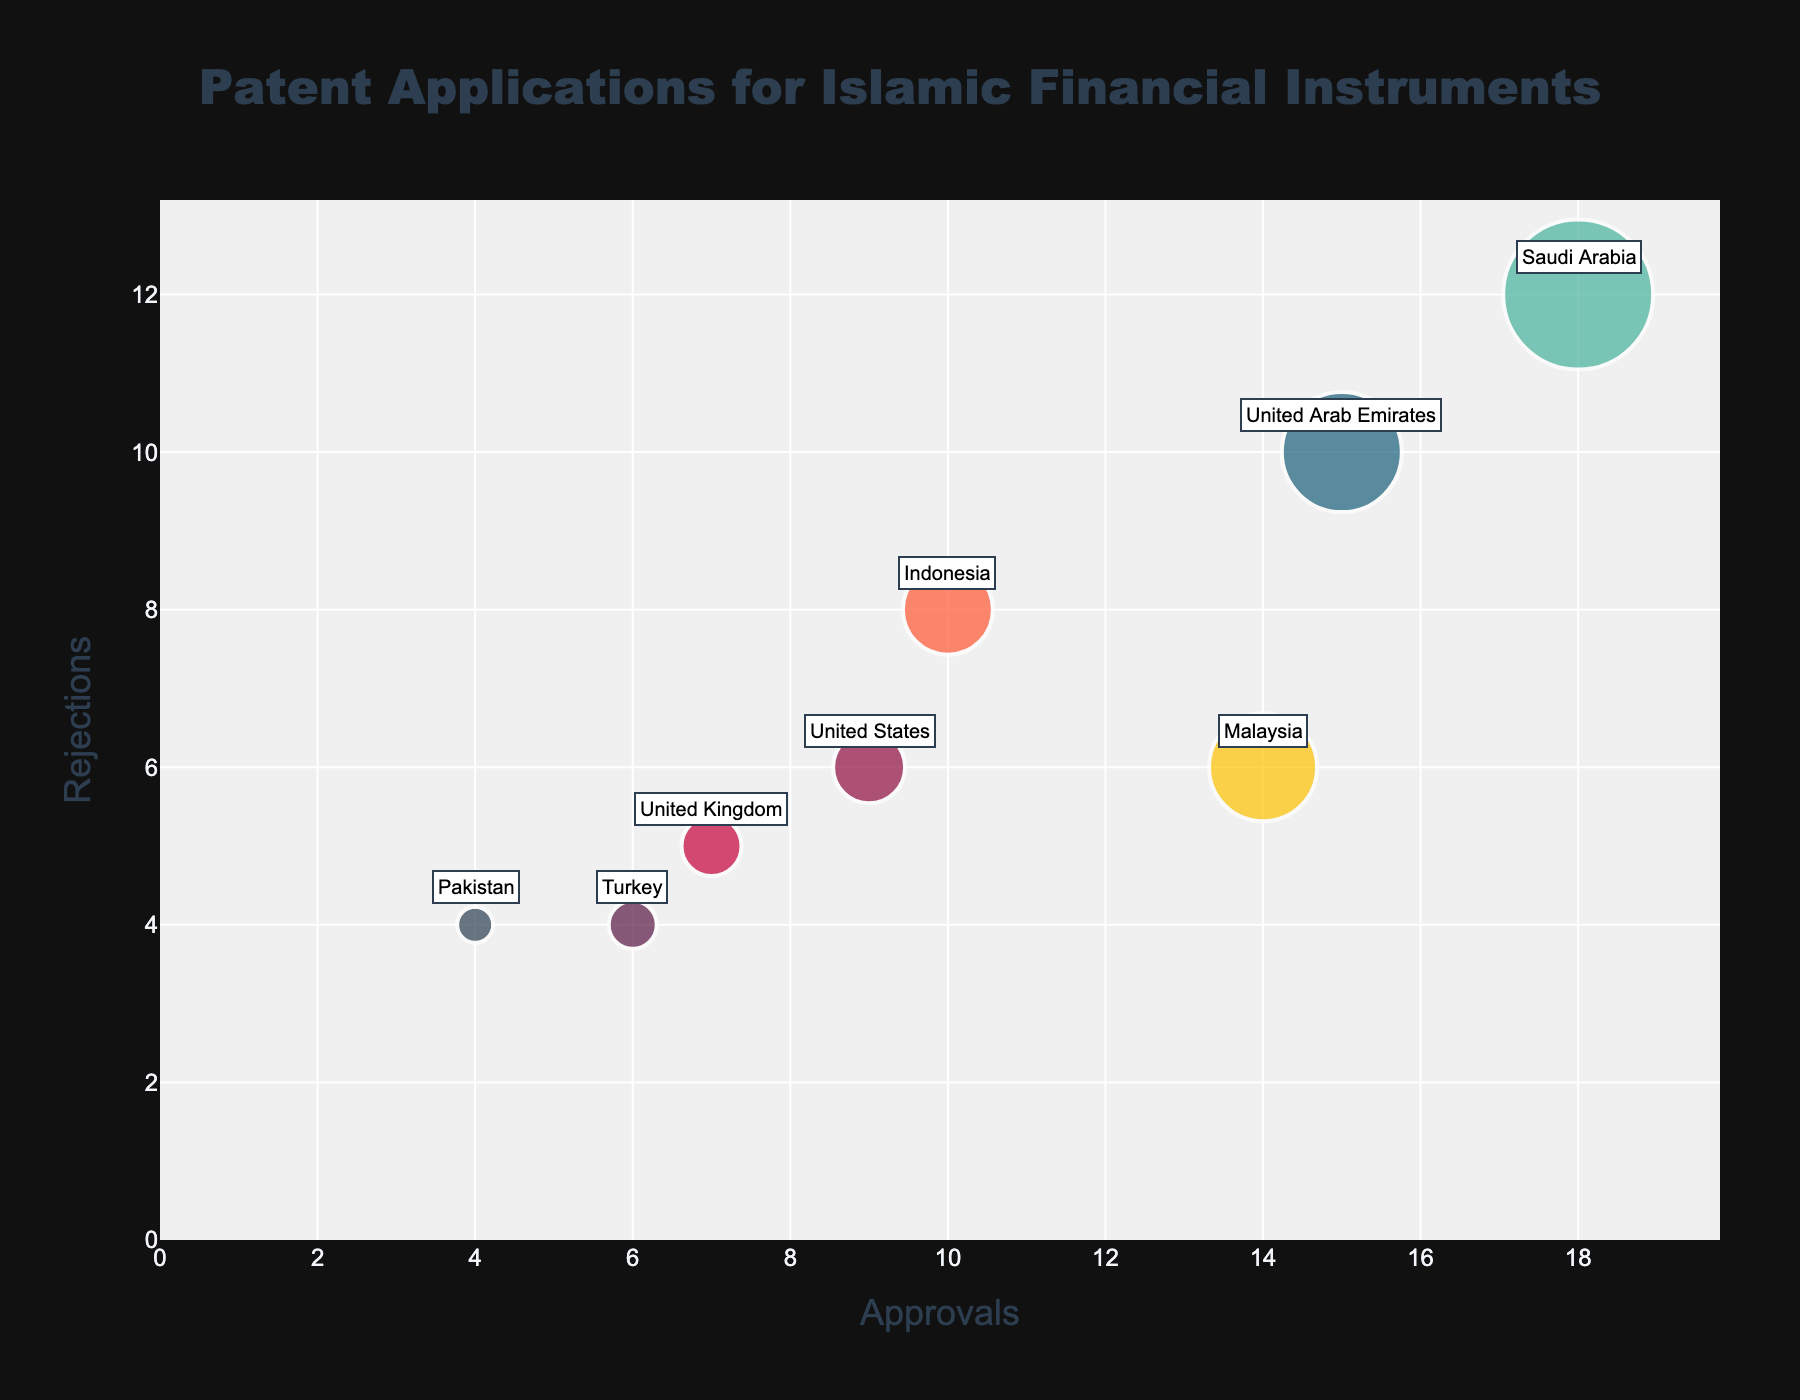what is the title of the figure? The title of the figure is displayed at the top of the chart. It reads "Patent Applications for Islamic Financial Instruments".
Answer: Patent Applications for Islamic Financial Instruments How many countries are represented in the chart? By counting the number of unique data points (bubbles) in the chart, we observe that there are various bubbles, each representing a different country. Upon inspection, we identify 8 distinct countries presented.
Answer: 8 Which country has the highest number of approvals? By examining the x-axis, which represents the number of approvals, and identifying the bubble that is farthest to the right, we see that Saudi Arabia has the highest number of approvals, with an approval count of 18.
Answer: Saudi Arabia What is the sum of rejections for Malaysia and Indonesia? To calculate this, we refer to the y-axis values for Malaysia and Indonesia. Malaysia has 6 rejections and Indonesia has 8 rejections. Adding these two values, 6 + 8, gives us 14.
Answer: 14 Which country has the smallest bubble size, and what does it represent? By identifying the smallest bubble on the chart, it corresponds to Pakistan. The bubble size represents the number of patent applications, and according to the given data, Pakistan has 8 patent applications.
Answer: Pakistan; 8 patent applications How many more approvals does the United States have compared to the United Kingdom? By checking the values on the x-axis, the United States has 9 approvals, and the United Kingdom has 7 approvals. Subtracting the two, 9 - 7, gives us that the United States has 2 more approvals than the United Kingdom.
Answer: 2 What is the average number of rejections across all countries? Adding up all the rejections: 10 (UAE) + 12 (Saudi Arabia) + 6 (Malaysia) + 8 (Indonesia) + 5 (UK) + 6 (US) + 4 (Turkey) + 4 (Pakistan) = 55. With 8 countries represented, the average is 55 / 8 = 6.875
Answer: 6.875 Explain why the UAE bubble appears larger than the UK's bubble even though they have fewer approvals. The size of the bubbles is not determined by the number of approvals but instead by BubbleSize, which is linked to the number of patent applications. The UAE has a BubbleSize of 20, while the UK has a BubbleSize of 10, meaning the UAE has more patent applications overall, resulting in a larger bubble.
Answer: BubbleSize is based on the number of applications Which two countries have an equal number of rejections and what is that number? By looking at the y-axis, both Turkey and Pakistan have bubbles that align with the y-axis value of 4, indicating that they both have 4 rejections each.
Answer: Turkey and Pakistan; 4 Which country has the closest ratio of approvals to rejections? To find the country with the closest ratio, we compare the values of approvals to rejections for each country. By inspection, Malaysia with 14 approvals and 6 rejections (ratio of 14/6 ≈ 2.33) has one of the closest ratios. Detailed analysis of ratios will show Malaysia as the closest.
Answer: Malaysia 